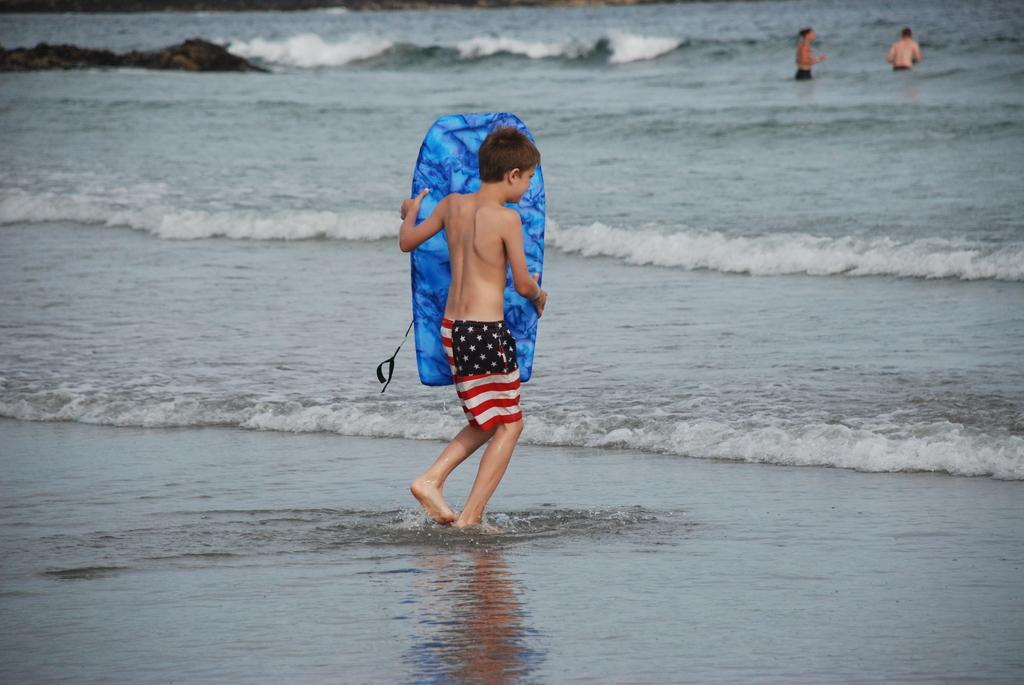How many people are in the image? There are people in the image, but the exact number is not specified. What is one person doing in the image? One person is holding an object in the image. What type of environment is depicted in the image? There is water and the ground visible in the image, suggesting an outdoor setting. What type of teeth can be seen on the horses in the image? There are no horses or teeth present in the image. 